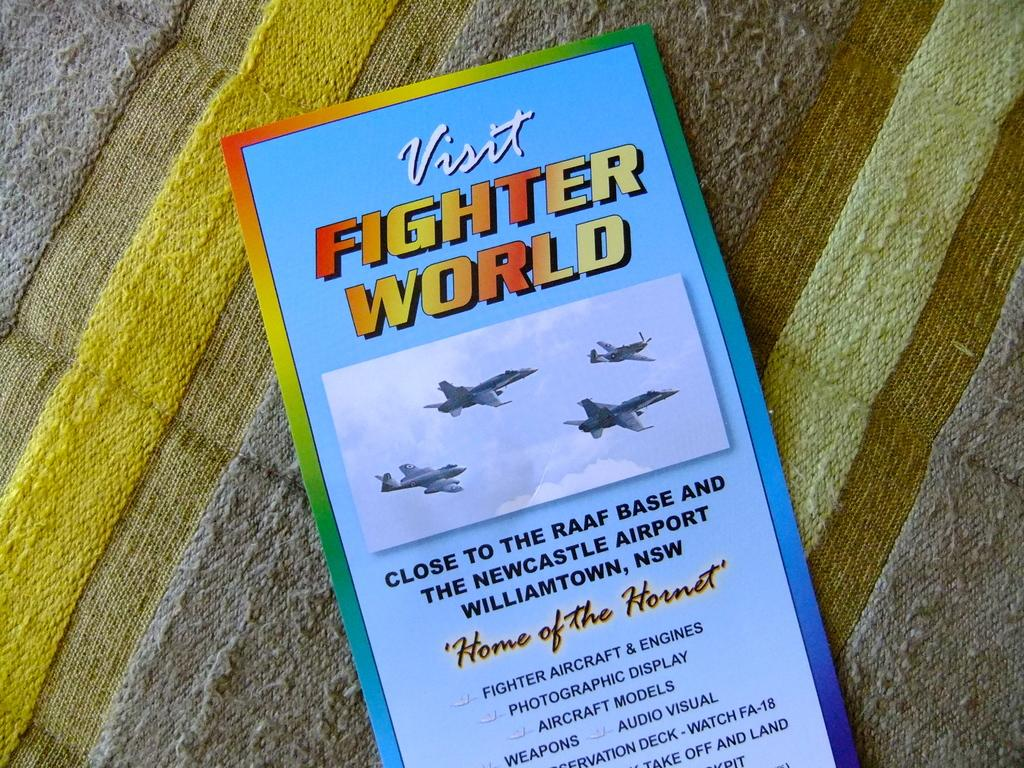<image>
Provide a brief description of the given image. Fighter World is the attraction that is being promoted. 